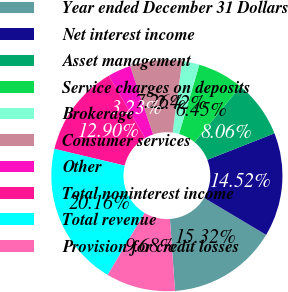<chart> <loc_0><loc_0><loc_500><loc_500><pie_chart><fcel>Year ended December 31 Dollars<fcel>Net interest income<fcel>Asset management<fcel>Service charges on deposits<fcel>Brokerage<fcel>Consumer services<fcel>Other<fcel>Total noninterest income<fcel>Total revenue<fcel>Provision for credit losses<nl><fcel>15.32%<fcel>14.52%<fcel>8.06%<fcel>6.45%<fcel>2.42%<fcel>7.26%<fcel>3.23%<fcel>12.9%<fcel>20.16%<fcel>9.68%<nl></chart> 